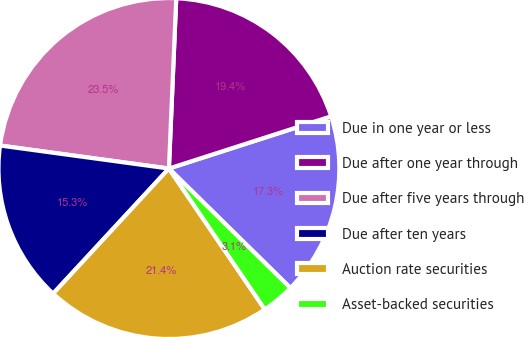<chart> <loc_0><loc_0><loc_500><loc_500><pie_chart><fcel>Due in one year or less<fcel>Due after one year through<fcel>Due after five years through<fcel>Due after ten years<fcel>Auction rate securities<fcel>Asset-backed securities<nl><fcel>17.32%<fcel>19.36%<fcel>23.53%<fcel>15.27%<fcel>21.4%<fcel>3.12%<nl></chart> 